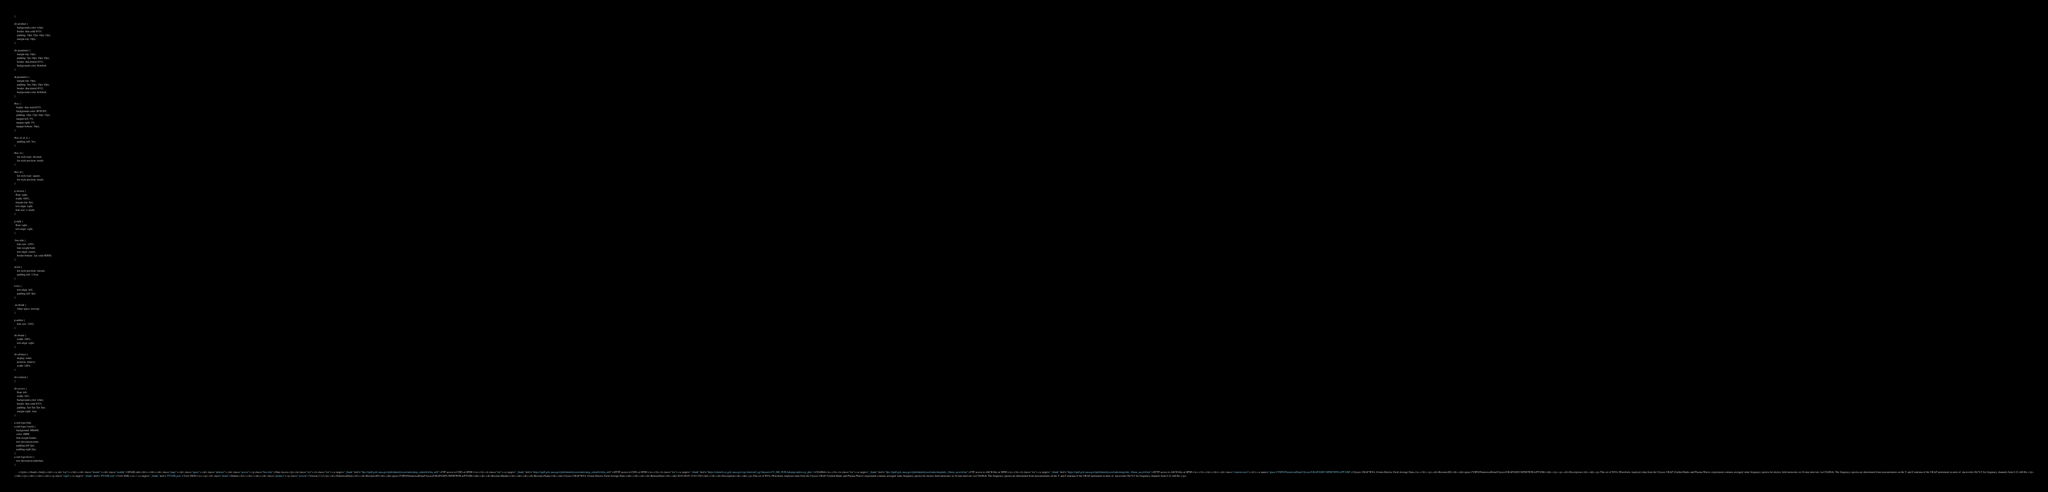Convert code to text. <code><loc_0><loc_0><loc_500><loc_500><_HTML_>}

div.product {
	background-color: white;
	border: thin solid #333;
	padding: 10px 15px 10px 15px;
	margin-top: 10px;
}

div.parameter {
	margin-top: 10px;
	padding: 5px 10px 10px 10px;
	border: thin dotted #333;
	background-color: #ebebeb;
}

dt.parameter {
	margin-top: 10px;
	padding: 5px 10px 10px 10px;
	border: thin dotted #333;
	background-color: #ebebeb;
}

#toc {
   border: thin solid #333;
   background-color: #F5F5F5; 
   padding: 10px 15px 10px 15px;
   margin-left: 5%;
   margin-right: 5%;
   margin-bottom: 30px;
}

#toc ol, ul, li {
	padding-left: 5ex;
}

#toc ol {
	list-style-type: decimal;
	list-style-position: inside; 
}

#toc ul {
	list-style-type: square;
	list-style-position: inside; 
}

p.version {
  float: right;
  width: 100%;
  margin-top: 5px;
  text-align: right;
  font-size: x-small;
}

p.right {
  float: right;
  text-align: right;
}

.box-title {
	font-size: 120%;
	font-weight:bold;
	text-align: center;
	border-bottom: 1px solid #DDD;
}

ul.list {
	list-style-position: outside;
	padding-left: 1.5em;
}

li.list {
	text-align: left;
	padding-left: 0px;
}

.no-break {
	white-space: nowrap;
}

p.author {
	font-size: 120%;
}

div.brand {
	width: 100%;
	text-align: right;
}

div.abstract {
	display: table;
	position: relative;
	width: 100%;
}

div.citation {
}

div.access {
	float: left;
	width: 20%;
	background-color: white;
	border: thin solid #333;
	padding: 5px 5px 5px 5px;
	margin-right: 1em;
}

a.xml-logo:link,
a.xml-logo:visited {
   background: #ff6600;
   color: #ffffff;
   font-weight:bolder; 
   text-decoration:none; 
   padding-left:2px;
   padding-right:2px;
}
a.xml-logo:hover {
   text-decoration:underline; 
}

	  </style></head><body><div><a id="top"/></div><div class="header"><div class="middle">SPASE.info</div></div><div class="page"><div class="spase"><div class="abstract"><div class="access"><p class="box-title">Data Access</p><ul class="list"><li class="list"><a target="_blank" href="ftps://spdf.gsfc.nasa.gov/pub/data/ulysses/radio/urap_cdaweb/wfea_m0/">FTP access to CDFs at SPDF</a></li><li class="list"><a target="_blank" href="https://spdf.gsfc.nasa.gov/pub/data/ulysses/radio/urap_cdaweb/wfea_m0/">HTTP access to CDFs at SPDF</a></li><li class="list"><a target="_blank" href="https://cdaweb.sci.gsfc.nasa.gov/cgi-bin/eval2.cgi?dataset=UY_M0_WFEA&amp;index=sp_phys">CDAWeb</a></li><li class="list"><a target="_blank" href="ftps://spdf.gsfc.nasa.gov/pub/data/ulysses/radio/urap/uds_10min_ascii/wfea/">FTP access to ASCII files at SPDF</a></li><li class="list"><a target="_blank" href="https://spdf.gsfc.nasa.gov/pub/data/ulysses/radio/urap/uds_10min_ascii/wfea/">HTTP access to ASCII files at SPDF</a></li></ul></div><div class="citation inset"><h1><a name="spase://VSPO/NumericalData/Ulysses/URAP/GSFC/SPDF/WFEA/PT10M">Ulysses URAP WFA 10-min Electric Field Average Data</a></h1><p><dt>ResourceID</dt><dd>spase://VSPO/NumericalData/Ulysses/URAP/GSFC/SPDF/WFEA/PT10M</dd></p><p><dt>Description</dt><dd><p>This set of WFA (Waveform Analyzer) data from the Ulysses URAP (Unified Radio and Plasma Waves) experiment contains averaged value frequency spectra for electric field intensities in 10-min intervals via CDAWeb. The frequency spectra are determined from measurements on the Y and Z antenna of the URAP instrument in units of  microvolts/ Hz^0.5 for frequency channels from 0.22-448 Hz.</p>
</dd></p></div></div><div><p class="right"><a target="_blank" href="PT10M.xml">View XML</a> | <a target="_blank" href="PT10M.json">View JSON</a></p><h1 class="detail">Details</h1></div><div><div class="product"><p class="version">Version:2.2.2</p><h1>NumericalData</h1><dt>ResourceID</dt><dd>spase://VSPO/NumericalData/Ulysses/URAP/GSFC/SPDF/WFEA/PT10M</dd><dl><dt>ResourceHeader</dt><dd><dl><dt>ResourceName</dt><dd>Ulysses URAP WFA 10-min Electric Field Average Data</dd></dl><dl><dt>ReleaseDate</dt><dd>2019-08-05 15:03:35Z</dd></dl><dt>Description</dt><dd><p>This set of WFA (Waveform Analyzer) data from the Ulysses URAP (Unified Radio and Plasma Waves) experiment contains averaged value frequency spectra for electric field intensities in 10-min intervals via CDAWeb. The frequency spectra are determined from measurements on the Y and Z antenna of the URAP instrument in units of  microvolts/ Hz^0.5 for frequency channels from 0.22-448 Hz.</p></code> 